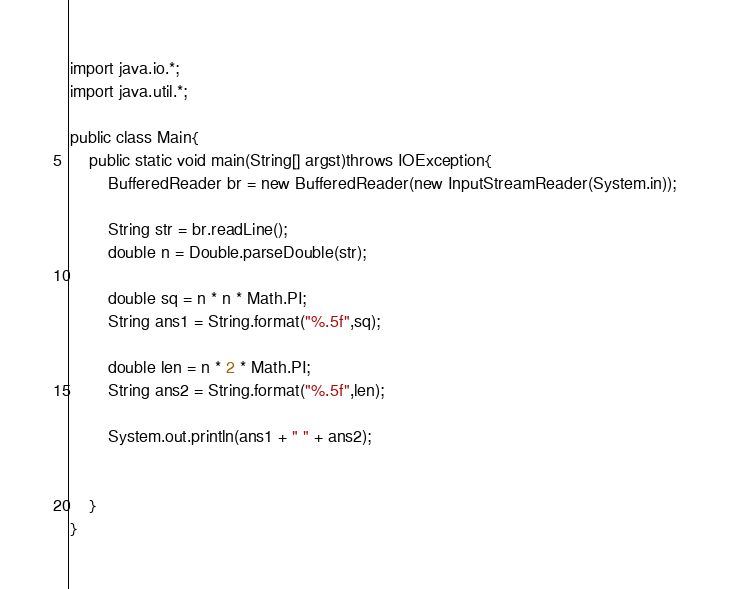<code> <loc_0><loc_0><loc_500><loc_500><_Java_>import java.io.*;
import java.util.*;

public class Main{
    public static void main(String[] argst)throws IOException{
        BufferedReader br = new BufferedReader(new InputStreamReader(System.in));
        
        String str = br.readLine();
        double n = Double.parseDouble(str);

        double sq = n * n * Math.PI;
        String ans1 = String.format("%.5f",sq);

        double len = n * 2 * Math.PI;
        String ans2 = String.format("%.5f",len);

        System.out.println(ans1 + " " + ans2);


    }
}</code> 